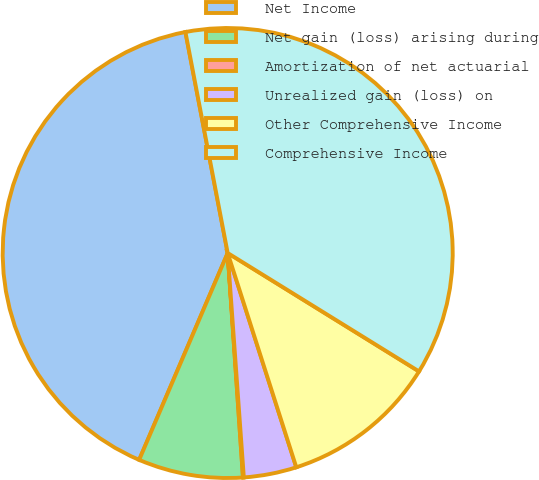<chart> <loc_0><loc_0><loc_500><loc_500><pie_chart><fcel>Net Income<fcel>Net gain (loss) arising during<fcel>Amortization of net actuarial<fcel>Unrealized gain (loss) on<fcel>Other Comprehensive Income<fcel>Comprehensive Income<nl><fcel>40.56%<fcel>7.52%<fcel>0.06%<fcel>3.79%<fcel>11.25%<fcel>36.83%<nl></chart> 